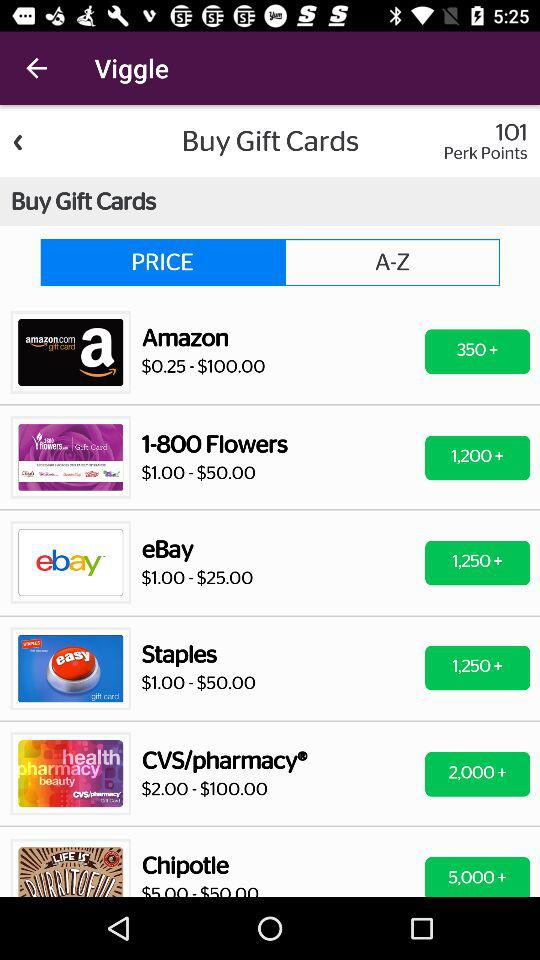What's the highest price of eBay Gift Card? The highest price of an eBay gift card is $25. 